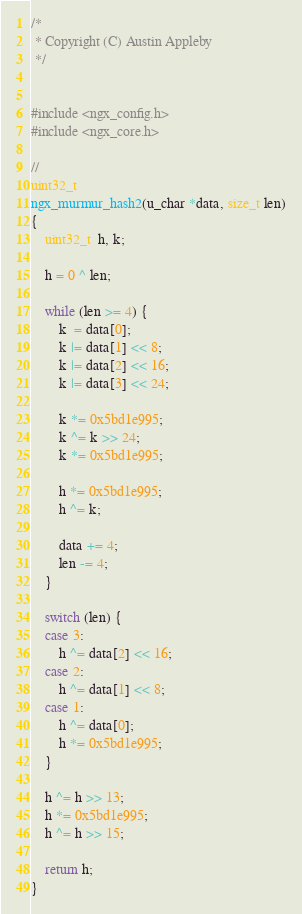Convert code to text. <code><loc_0><loc_0><loc_500><loc_500><_C_>
/*
 * Copyright (C) Austin Appleby
 */


#include <ngx_config.h>
#include <ngx_core.h>

//
uint32_t
ngx_murmur_hash2(u_char *data, size_t len)
{
    uint32_t  h, k;

    h = 0 ^ len;

    while (len >= 4) {
        k  = data[0];
        k |= data[1] << 8;
        k |= data[2] << 16;
        k |= data[3] << 24;

        k *= 0x5bd1e995;
        k ^= k >> 24;
        k *= 0x5bd1e995;

        h *= 0x5bd1e995;
        h ^= k;

        data += 4;
        len -= 4;
    }

    switch (len) {
    case 3:
        h ^= data[2] << 16;
    case 2:
        h ^= data[1] << 8;
    case 1:
        h ^= data[0];
        h *= 0x5bd1e995;
    }

    h ^= h >> 13;
    h *= 0x5bd1e995;
    h ^= h >> 15;

    return h;
}
</code> 